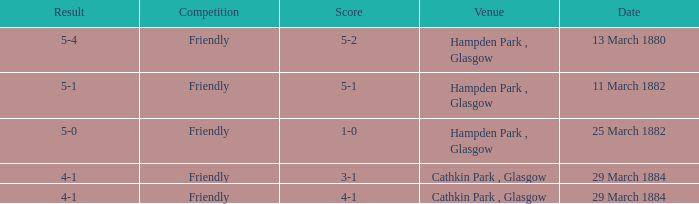Which item resulted in a score of 4-1? 3-1, 4-1. 